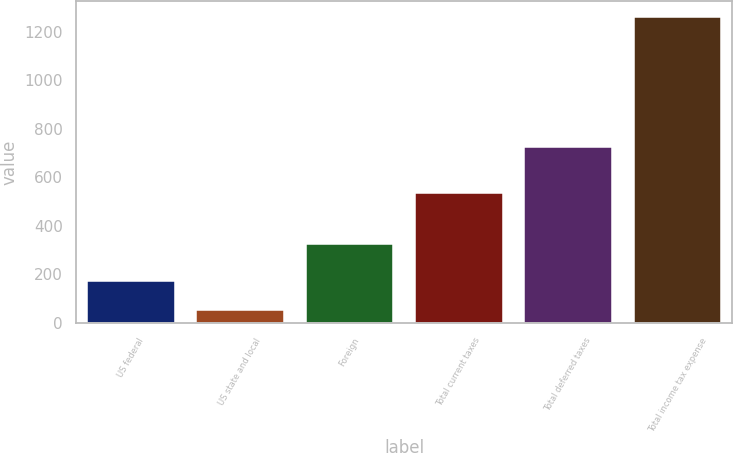Convert chart. <chart><loc_0><loc_0><loc_500><loc_500><bar_chart><fcel>US federal<fcel>US state and local<fcel>Foreign<fcel>Total current taxes<fcel>Total deferred taxes<fcel>Total income tax expense<nl><fcel>173<fcel>52<fcel>327<fcel>535.2<fcel>726.8<fcel>1262<nl></chart> 